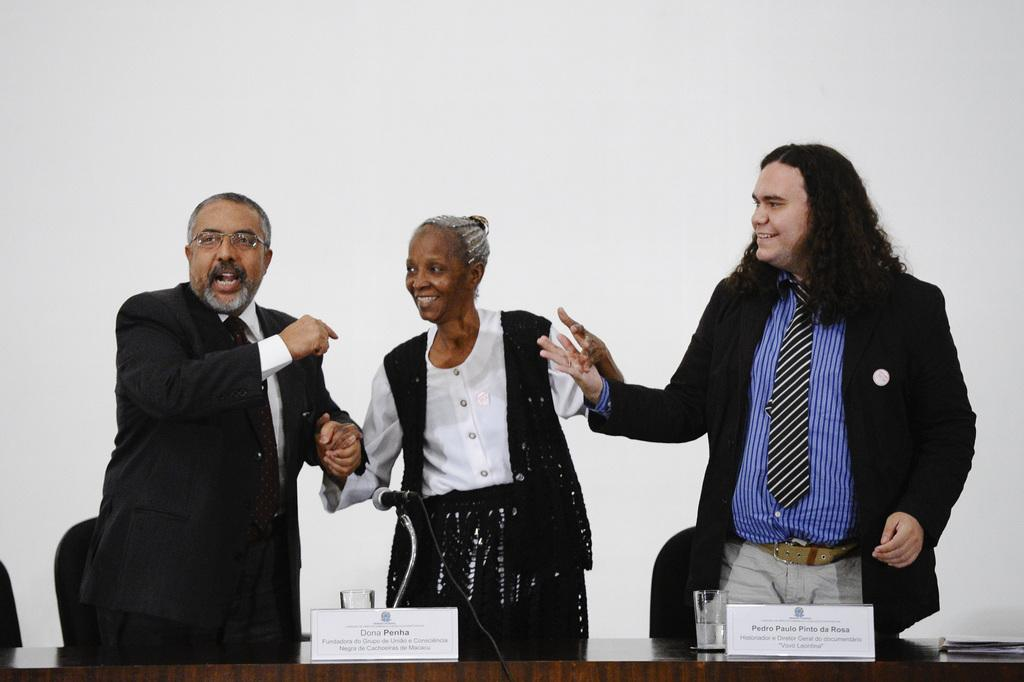What is the main object in the image? There is a table in the image. What are the people in the image doing? There are persons standing at the table. What can be seen on the table? There is a mic and a glass on the table. What is visible in the background of the image? There is a wall and a chair in the background of the image. What is the purpose of the board in the image? The purpose of the board in the image is not clear from the facts provided. How many feet are visible on the apparatus in the image? There is no apparatus present in the image, and therefore no feet can be observed. 